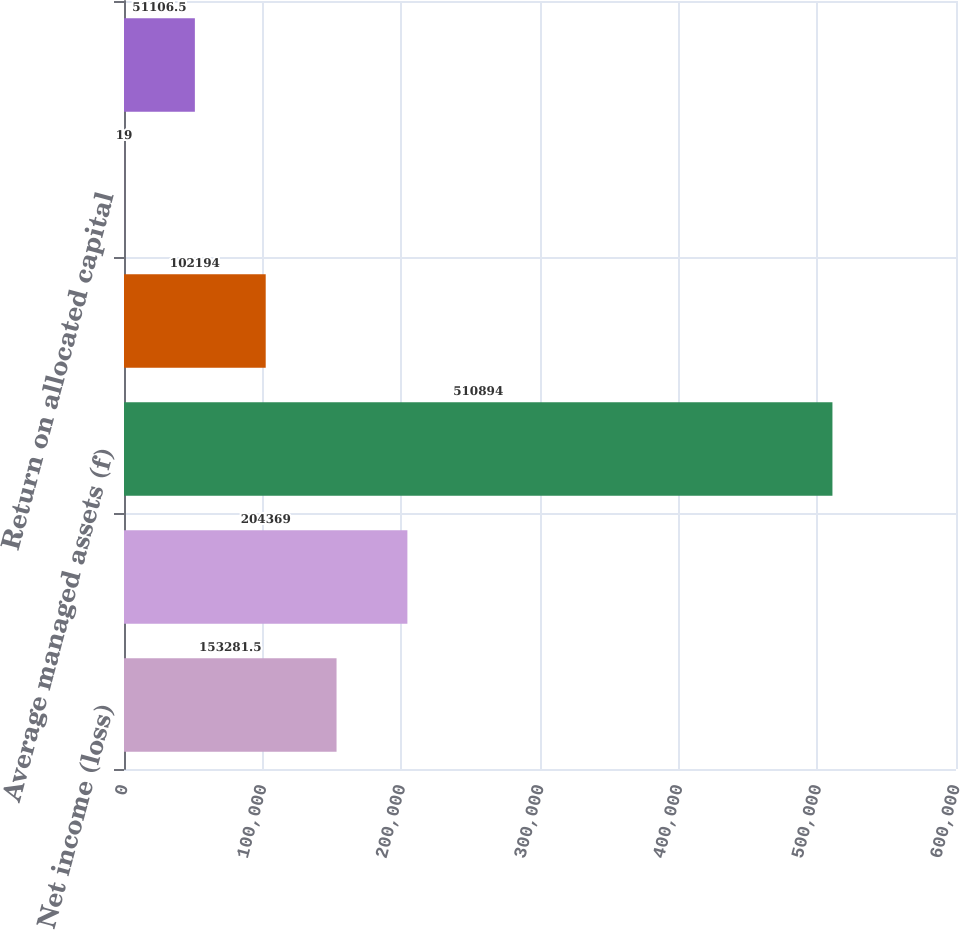<chart> <loc_0><loc_0><loc_500><loc_500><bar_chart><fcel>Net income (loss)<fcel>Average allocated capital<fcel>Average managed assets (f)<fcel>Shareholder value added<fcel>Return on allocated capital<fcel>Overhead ratio<nl><fcel>153282<fcel>204369<fcel>510894<fcel>102194<fcel>19<fcel>51106.5<nl></chart> 